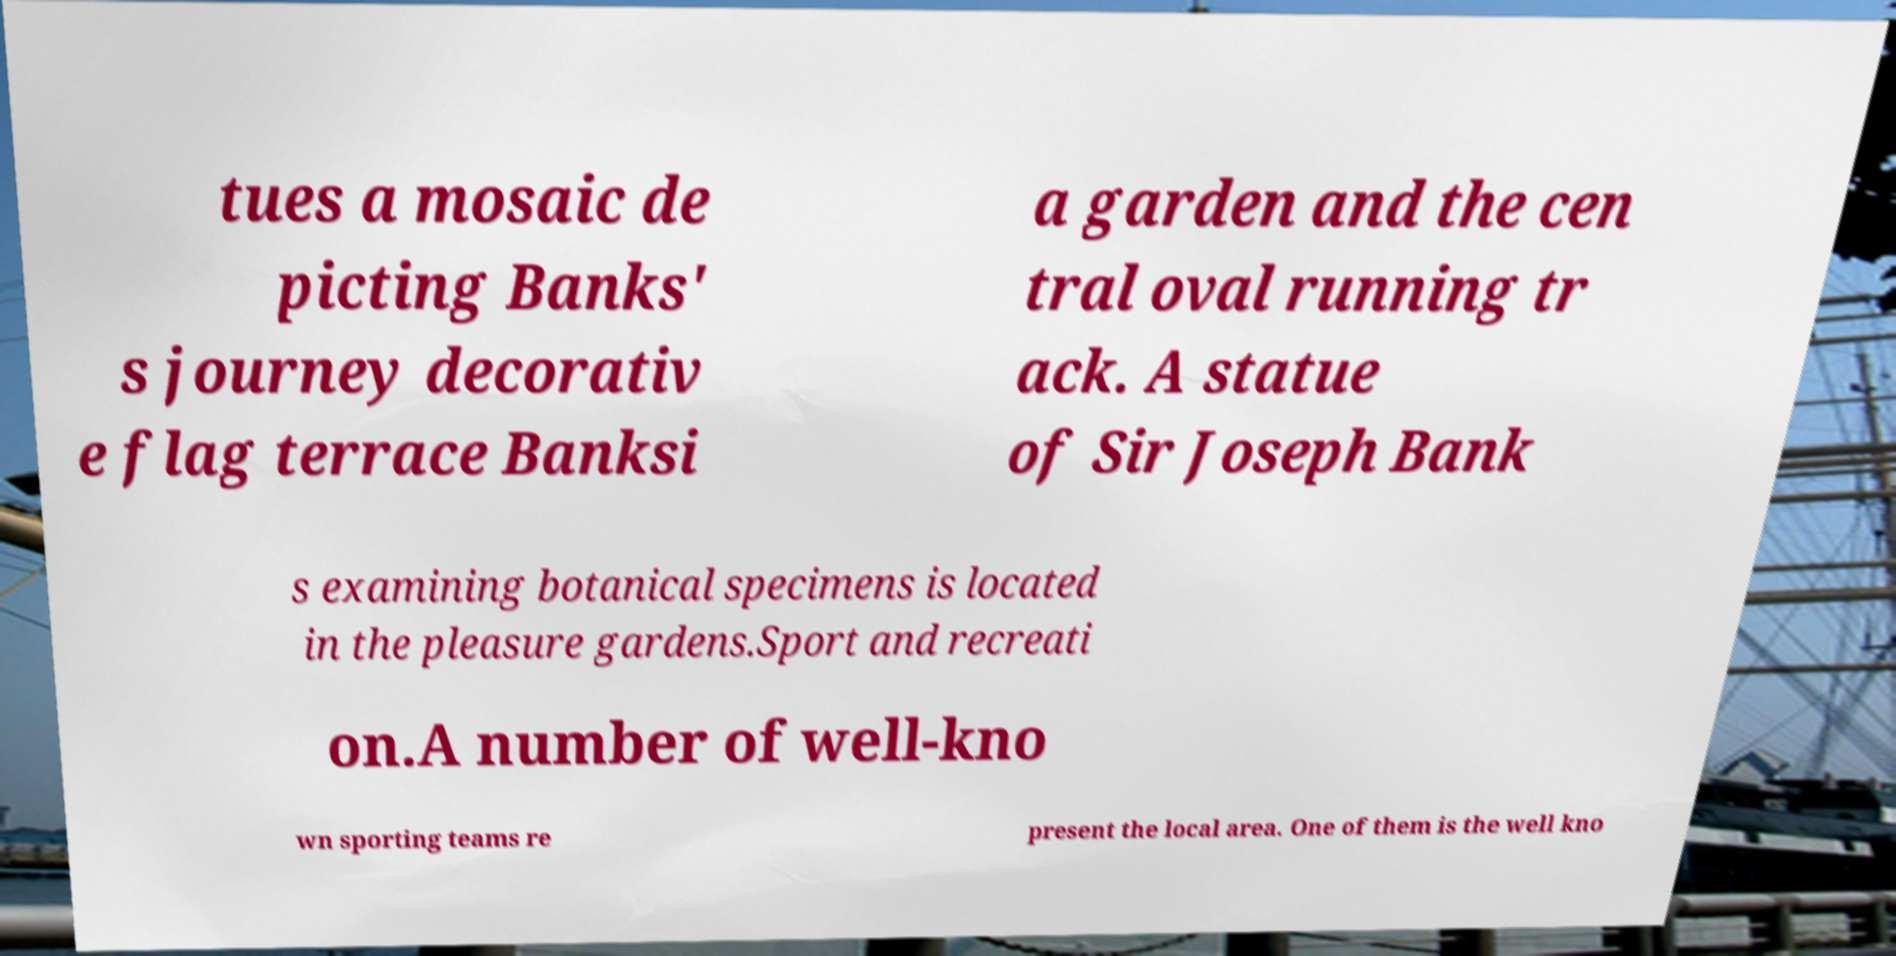Please read and relay the text visible in this image. What does it say? tues a mosaic de picting Banks' s journey decorativ e flag terrace Banksi a garden and the cen tral oval running tr ack. A statue of Sir Joseph Bank s examining botanical specimens is located in the pleasure gardens.Sport and recreati on.A number of well-kno wn sporting teams re present the local area. One of them is the well kno 